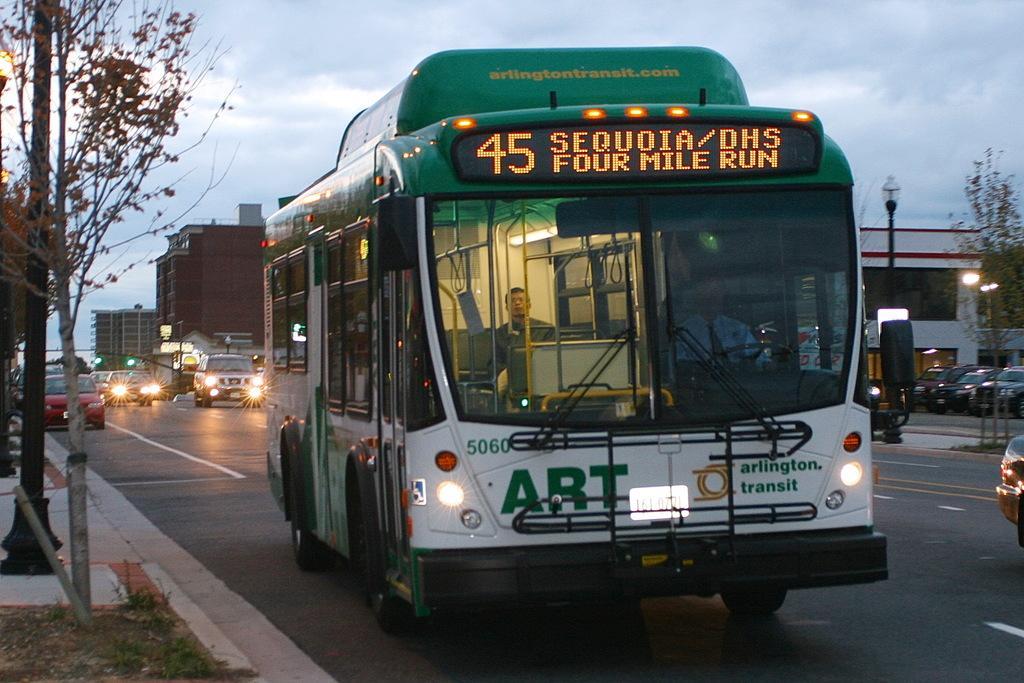Describe this image in one or two sentences. In this image we can see a bus. In the bus we can see two persons and on the bus we can see some text. Behind the bus we can see few vehicles and buildings. At the top we can see the sky. On the left side, we can see trees, plants and a pole. On the right side, we can see pole trees, pole, lights and a few vehicles. 